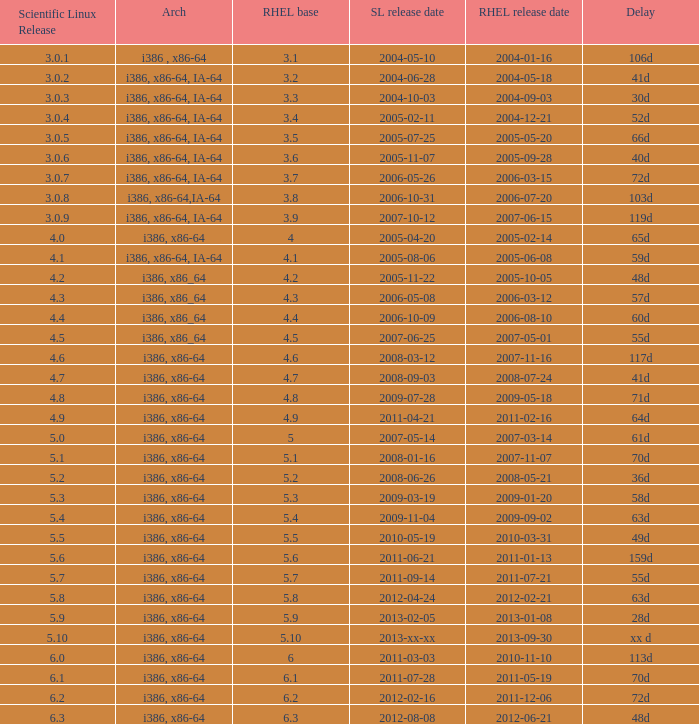Parse the table in full. {'header': ['Scientific Linux Release', 'Arch', 'RHEL base', 'SL release date', 'RHEL release date', 'Delay'], 'rows': [['3.0.1', 'i386 , x86-64', '3.1', '2004-05-10', '2004-01-16', '106d'], ['3.0.2', 'i386, x86-64, IA-64', '3.2', '2004-06-28', '2004-05-18', '41d'], ['3.0.3', 'i386, x86-64, IA-64', '3.3', '2004-10-03', '2004-09-03', '30d'], ['3.0.4', 'i386, x86-64, IA-64', '3.4', '2005-02-11', '2004-12-21', '52d'], ['3.0.5', 'i386, x86-64, IA-64', '3.5', '2005-07-25', '2005-05-20', '66d'], ['3.0.6', 'i386, x86-64, IA-64', '3.6', '2005-11-07', '2005-09-28', '40d'], ['3.0.7', 'i386, x86-64, IA-64', '3.7', '2006-05-26', '2006-03-15', '72d'], ['3.0.8', 'i386, x86-64,IA-64', '3.8', '2006-10-31', '2006-07-20', '103d'], ['3.0.9', 'i386, x86-64, IA-64', '3.9', '2007-10-12', '2007-06-15', '119d'], ['4.0', 'i386, x86-64', '4', '2005-04-20', '2005-02-14', '65d'], ['4.1', 'i386, x86-64, IA-64', '4.1', '2005-08-06', '2005-06-08', '59d'], ['4.2', 'i386, x86_64', '4.2', '2005-11-22', '2005-10-05', '48d'], ['4.3', 'i386, x86_64', '4.3', '2006-05-08', '2006-03-12', '57d'], ['4.4', 'i386, x86_64', '4.4', '2006-10-09', '2006-08-10', '60d'], ['4.5', 'i386, x86_64', '4.5', '2007-06-25', '2007-05-01', '55d'], ['4.6', 'i386, x86-64', '4.6', '2008-03-12', '2007-11-16', '117d'], ['4.7', 'i386, x86-64', '4.7', '2008-09-03', '2008-07-24', '41d'], ['4.8', 'i386, x86-64', '4.8', '2009-07-28', '2009-05-18', '71d'], ['4.9', 'i386, x86-64', '4.9', '2011-04-21', '2011-02-16', '64d'], ['5.0', 'i386, x86-64', '5', '2007-05-14', '2007-03-14', '61d'], ['5.1', 'i386, x86-64', '5.1', '2008-01-16', '2007-11-07', '70d'], ['5.2', 'i386, x86-64', '5.2', '2008-06-26', '2008-05-21', '36d'], ['5.3', 'i386, x86-64', '5.3', '2009-03-19', '2009-01-20', '58d'], ['5.4', 'i386, x86-64', '5.4', '2009-11-04', '2009-09-02', '63d'], ['5.5', 'i386, x86-64', '5.5', '2010-05-19', '2010-03-31', '49d'], ['5.6', 'i386, x86-64', '5.6', '2011-06-21', '2011-01-13', '159d'], ['5.7', 'i386, x86-64', '5.7', '2011-09-14', '2011-07-21', '55d'], ['5.8', 'i386, x86-64', '5.8', '2012-04-24', '2012-02-21', '63d'], ['5.9', 'i386, x86-64', '5.9', '2013-02-05', '2013-01-08', '28d'], ['5.10', 'i386, x86-64', '5.10', '2013-xx-xx', '2013-09-30', 'xx d'], ['6.0', 'i386, x86-64', '6', '2011-03-03', '2010-11-10', '113d'], ['6.1', 'i386, x86-64', '6.1', '2011-07-28', '2011-05-19', '70d'], ['6.2', 'i386, x86-64', '6.2', '2012-02-16', '2011-12-06', '72d'], ['6.3', 'i386, x86-64', '6.3', '2012-08-08', '2012-06-21', '48d']]} Name the scientific linux release when delay is 28d 5.9. 